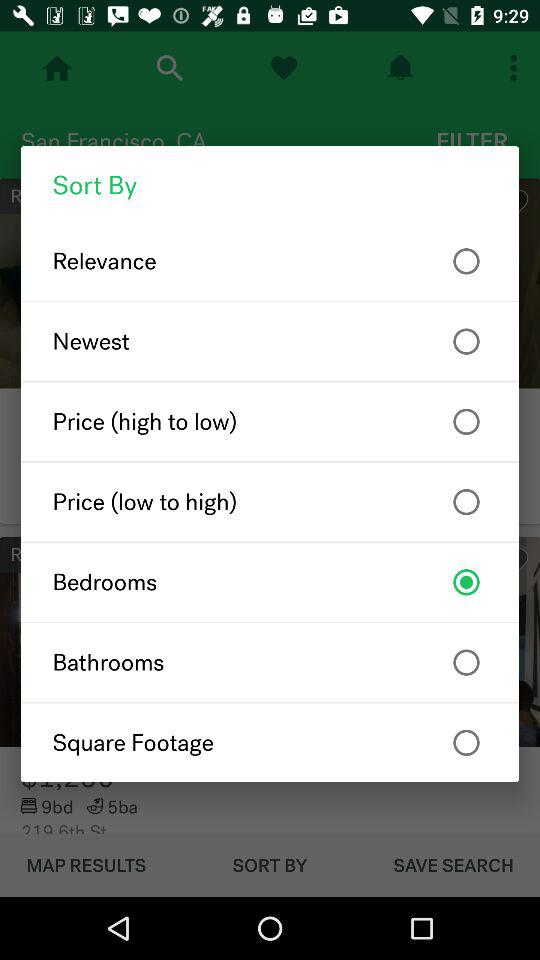What is the selected option? The selected option is "Bedrooms". 